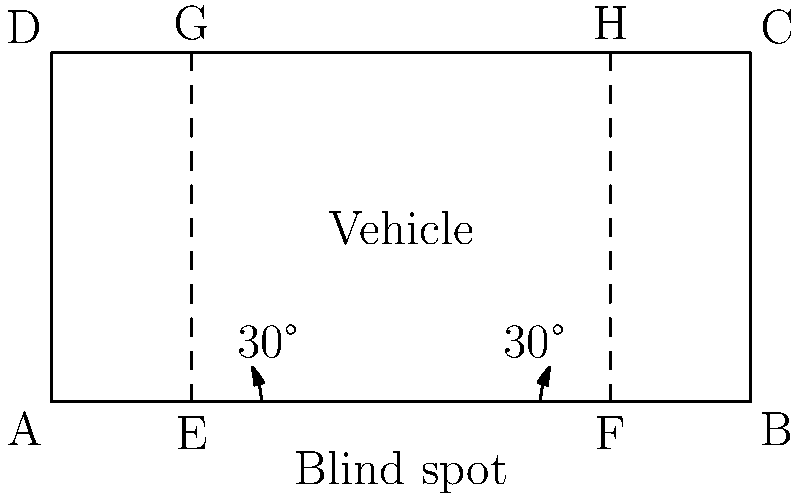A vehicle's side mirrors are adjusted to create a 30° angle with the side of the vehicle, as shown in the diagram. The vehicle is 5 meters long and 2.5 meters wide. Determine the area of the blind spot triangle formed behind the vehicle, assuming the mirrors' field of view extends to the rear corners of the vehicle. Let's approach this step-by-step:

1) First, we need to find the length of the blind spot triangle's base. This is the distance between points E and F in the diagram.

   EF = Vehicle length - 2 * (Vehicle width * tan(30°))
   EF = 5 - 2 * (2.5 * tan(30°))
   EF = 5 - 2 * (2.5 * 0.577) ≈ 2.12 meters

2) Now, we need to find the height of the triangle. This is the distance from the midpoint of EF to the rear of the vehicle.

   Height = Vehicle width / tan(30°)
   Height = 2.5 / tan(30°)
   Height = 2.5 / 0.577 ≈ 4.33 meters

3) We can now calculate the area of the triangle using the formula:
   
   Area = (1/2) * base * height
   Area = (1/2) * 2.12 * 4.33
   Area ≈ 4.59 square meters

Therefore, the area of the blind spot triangle is approximately 4.59 square meters.
Answer: 4.59 m² 